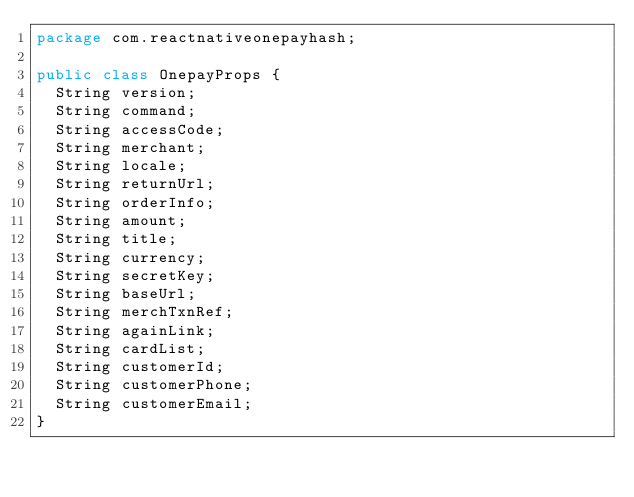<code> <loc_0><loc_0><loc_500><loc_500><_Java_>package com.reactnativeonepayhash;

public class OnepayProps {
  String version;
  String command;
  String accessCode;
  String merchant;
  String locale;
  String returnUrl;
  String orderInfo;
  String amount;
  String title;
  String currency;
  String secretKey;
  String baseUrl;
  String merchTxnRef;
  String againLink;
  String cardList;
  String customerId;
  String customerPhone;
  String customerEmail;
}
</code> 